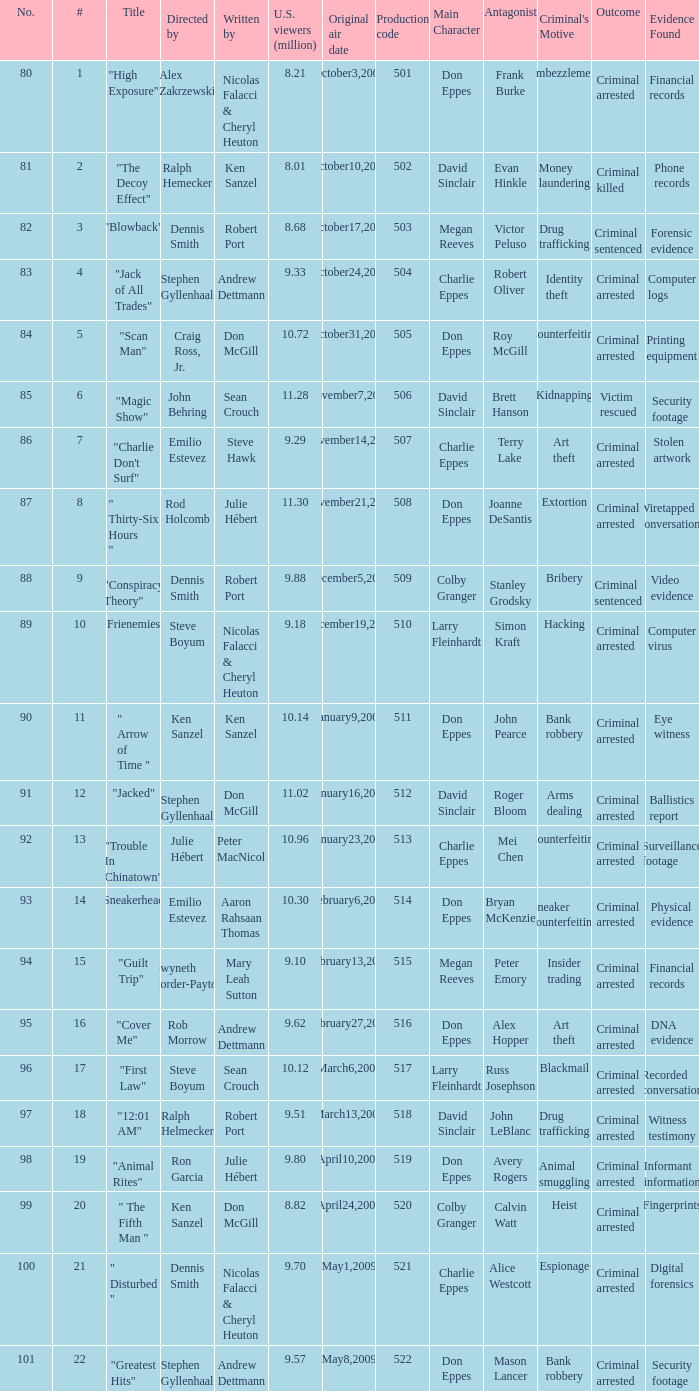How many times did episode 6 originally air? 1.0. 